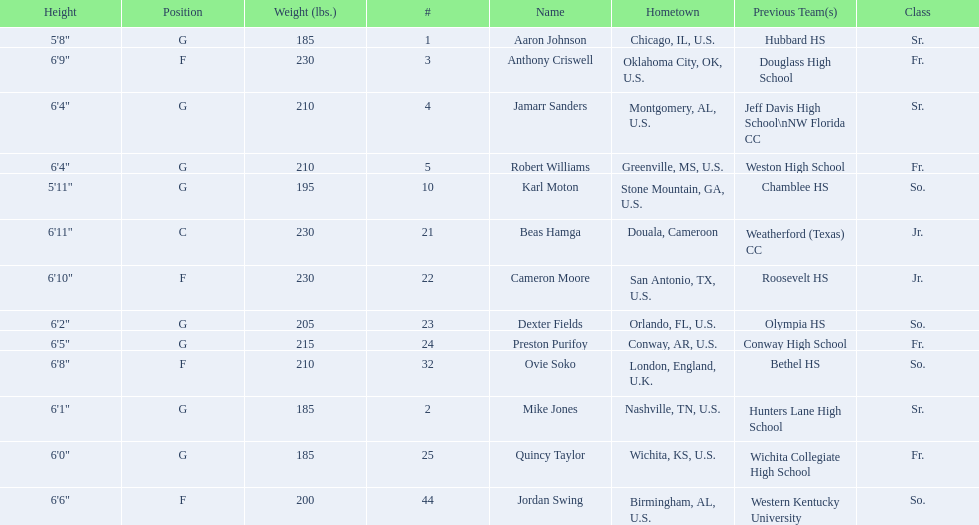Other than soko, tell me a player who is not from the us. Beas Hamga. 